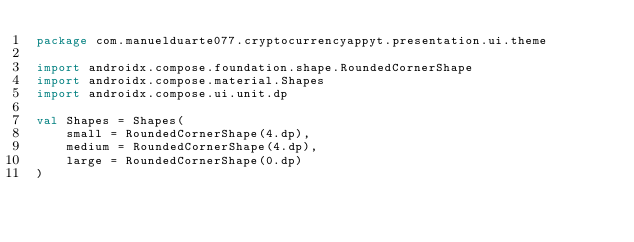Convert code to text. <code><loc_0><loc_0><loc_500><loc_500><_Kotlin_>package com.manuelduarte077.cryptocurrencyappyt.presentation.ui.theme

import androidx.compose.foundation.shape.RoundedCornerShape
import androidx.compose.material.Shapes
import androidx.compose.ui.unit.dp

val Shapes = Shapes(
    small = RoundedCornerShape(4.dp),
    medium = RoundedCornerShape(4.dp),
    large = RoundedCornerShape(0.dp)
)</code> 